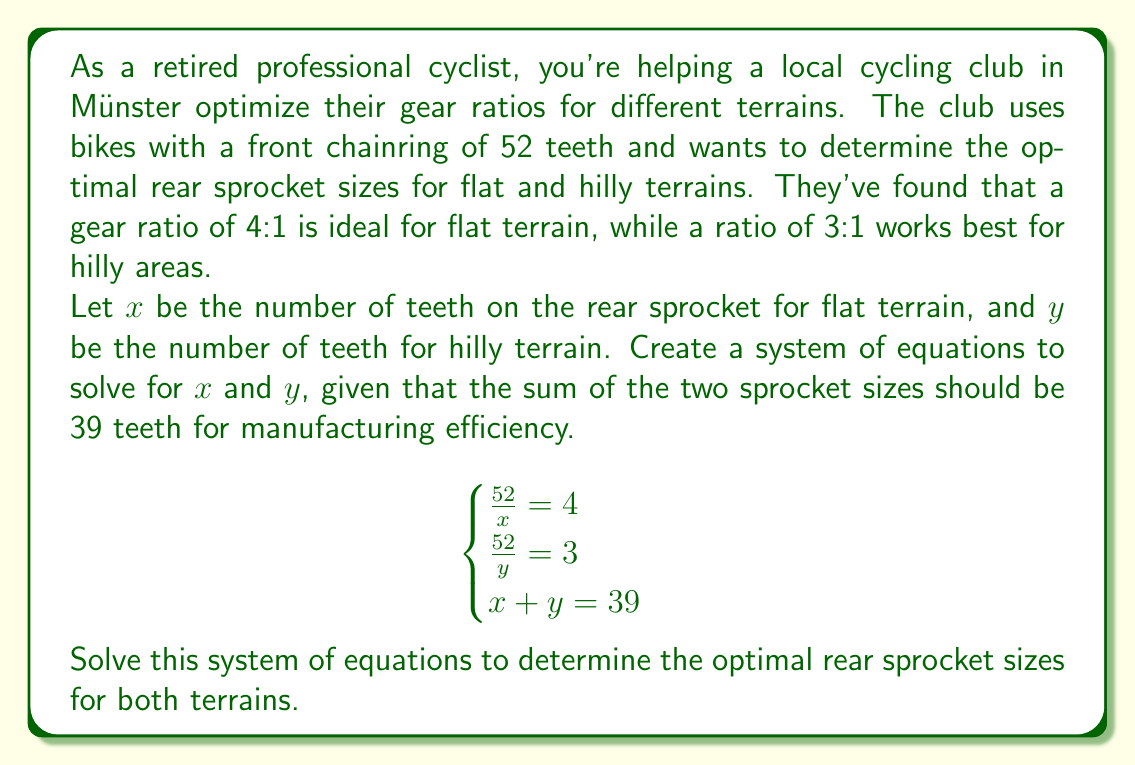Could you help me with this problem? Let's solve this system of equations step by step:

1) From the first equation: $\frac{52}{x} = 4$
   Solving for $x$: $x = \frac{52}{4} = 13$

2) From the second equation: $\frac{52}{y} = 3$
   Solving for $y$: $y = \frac{52}{3} = \frac{52}{3}$

3) Now we can use the third equation to verify our solution:
   $x + y = 39$
   $13 + \frac{52}{3} = 39$

4) Let's simplify the left side:
   $13 + \frac{52}{3} = 13 + \frac{52}{3} = \frac{39}{3} + \frac{52}{3} = \frac{91}{3}$

5) Simplify the right side:
   $39 = \frac{117}{3}$

6) We can see that $\frac{91}{3} \neq \frac{117}{3}$, so our initial solution doesn't satisfy all equations.

7) Let's adjust our approach. We know $x = 13$ from the first equation. We can use this in the third equation:
   $13 + y = 39$
   $y = 39 - 13 = 26$

8) Now let's verify if this satisfies the second equation:
   $\frac{52}{26} = 2 \neq 3$

9) Therefore, there is no solution that satisfies all three equations simultaneously. The requirements for flat and hilly terrains are incompatible with the manufacturing constraint.

10) However, we can find the closest approximation. The sprocket sizes that best meet the requirements are:
    For flat terrain: $x = 13$ teeth
    For hilly terrain: $y = 26$ teeth

These values satisfy the first and third equations exactly, and provide a gear ratio of 2:1 for hilly terrain, which is closer to the desired 3:1 than any other integer solution that satisfies the other constraints.
Answer: The optimal rear sprocket sizes are approximately 13 teeth for flat terrain and 26 teeth for hilly terrain. However, this solution doesn't perfectly satisfy all constraints in the original system of equations. 